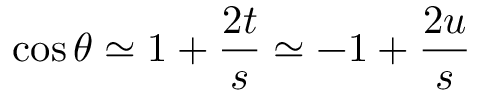Convert formula to latex. <formula><loc_0><loc_0><loc_500><loc_500>\cos \theta \simeq 1 + { \frac { 2 t } { s } } \simeq - 1 + { \frac { 2 u } { s } }</formula> 